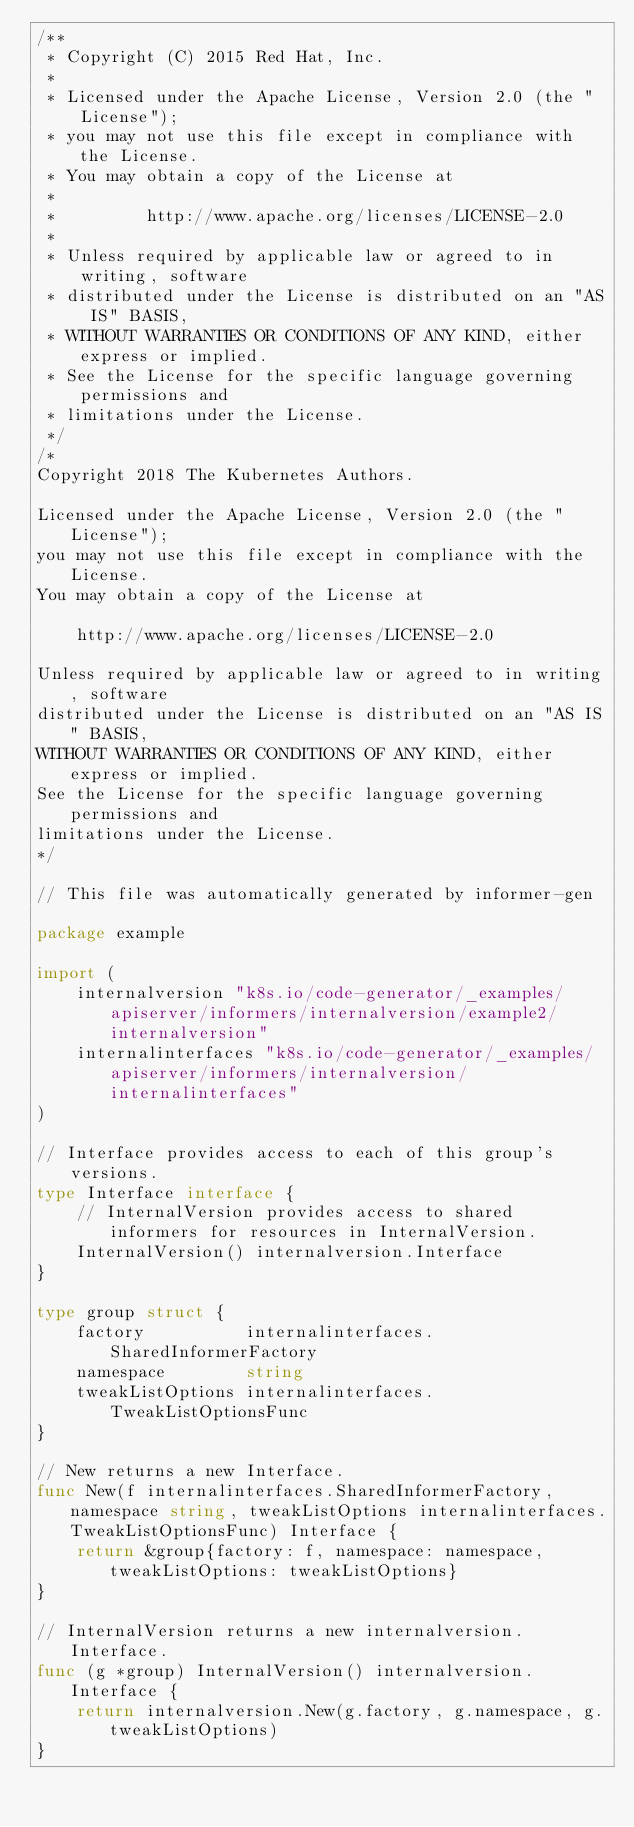Convert code to text. <code><loc_0><loc_0><loc_500><loc_500><_Go_>/**
 * Copyright (C) 2015 Red Hat, Inc.
 *
 * Licensed under the Apache License, Version 2.0 (the "License");
 * you may not use this file except in compliance with the License.
 * You may obtain a copy of the License at
 *
 *         http://www.apache.org/licenses/LICENSE-2.0
 *
 * Unless required by applicable law or agreed to in writing, software
 * distributed under the License is distributed on an "AS IS" BASIS,
 * WITHOUT WARRANTIES OR CONDITIONS OF ANY KIND, either express or implied.
 * See the License for the specific language governing permissions and
 * limitations under the License.
 */
/*
Copyright 2018 The Kubernetes Authors.

Licensed under the Apache License, Version 2.0 (the "License");
you may not use this file except in compliance with the License.
You may obtain a copy of the License at

    http://www.apache.org/licenses/LICENSE-2.0

Unless required by applicable law or agreed to in writing, software
distributed under the License is distributed on an "AS IS" BASIS,
WITHOUT WARRANTIES OR CONDITIONS OF ANY KIND, either express or implied.
See the License for the specific language governing permissions and
limitations under the License.
*/

// This file was automatically generated by informer-gen

package example

import (
	internalversion "k8s.io/code-generator/_examples/apiserver/informers/internalversion/example2/internalversion"
	internalinterfaces "k8s.io/code-generator/_examples/apiserver/informers/internalversion/internalinterfaces"
)

// Interface provides access to each of this group's versions.
type Interface interface {
	// InternalVersion provides access to shared informers for resources in InternalVersion.
	InternalVersion() internalversion.Interface
}

type group struct {
	factory          internalinterfaces.SharedInformerFactory
	namespace        string
	tweakListOptions internalinterfaces.TweakListOptionsFunc
}

// New returns a new Interface.
func New(f internalinterfaces.SharedInformerFactory, namespace string, tweakListOptions internalinterfaces.TweakListOptionsFunc) Interface {
	return &group{factory: f, namespace: namespace, tweakListOptions: tweakListOptions}
}

// InternalVersion returns a new internalversion.Interface.
func (g *group) InternalVersion() internalversion.Interface {
	return internalversion.New(g.factory, g.namespace, g.tweakListOptions)
}
</code> 